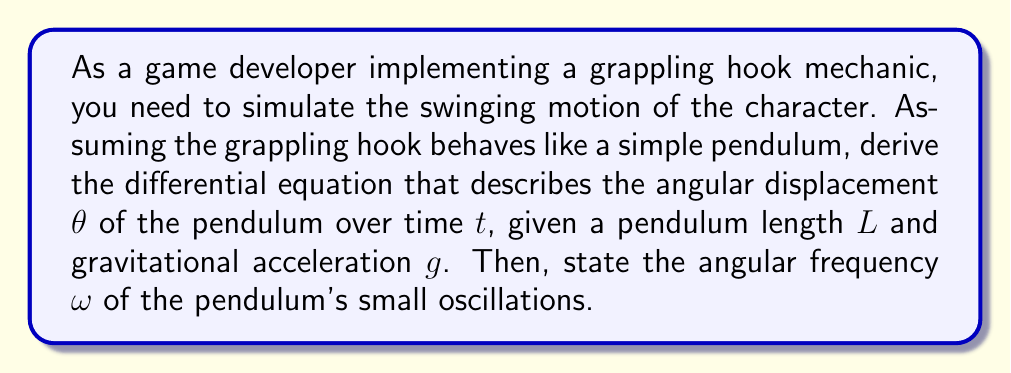Could you help me with this problem? To derive the differential equation for a simple pendulum and find its angular frequency, we'll follow these steps:

1) First, let's consider the forces acting on the pendulum bob:
   - Tension $T$ along the rope
   - Gravitational force $mg$ downward

2) We can resolve the gravitational force into two components:
   - $mg \cos\theta$ along the rope
   - $mg \sin\theta$ perpendicular to the rope

3) The tangential acceleration of the bob is $L\frac{d^2\theta}{dt^2}$

4) Applying Newton's Second Law in the tangential direction:

   $$-mg \sin\theta = mL\frac{d^2\theta}{dt^2}$$

5) Simplify by dividing both sides by $mL$:

   $$\frac{d^2\theta}{dt^2} + \frac{g}{L}\sin\theta = 0$$

This is the nonlinear pendulum equation.

6) For small oscillations, $\sin\theta \approx \theta$, so we can approximate:

   $$\frac{d^2\theta}{dt^2} + \frac{g}{L}\theta = 0$$

7) This is in the form of a simple harmonic oscillator equation:

   $$\frac{d^2\theta}{dt^2} + \omega^2\theta = 0$$

8) By comparison, we can see that the angular frequency $\omega$ is:

   $$\omega = \sqrt{\frac{g}{L}}$$

This angular frequency applies to small oscillations of the pendulum.
Answer: The differential equation for the pendulum motion is:

$$\frac{d^2\theta}{dt^2} + \frac{g}{L}\sin\theta = 0$$

The angular frequency for small oscillations is:

$$\omega = \sqrt{\frac{g}{L}}$$ 